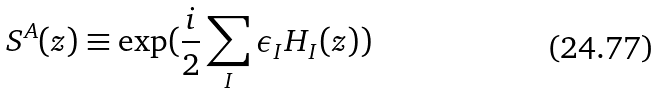Convert formula to latex. <formula><loc_0><loc_0><loc_500><loc_500>S ^ { A } ( z ) \equiv \exp ( \frac { i } { 2 } \sum _ { I } \epsilon _ { I } H _ { I } ( z ) )</formula> 